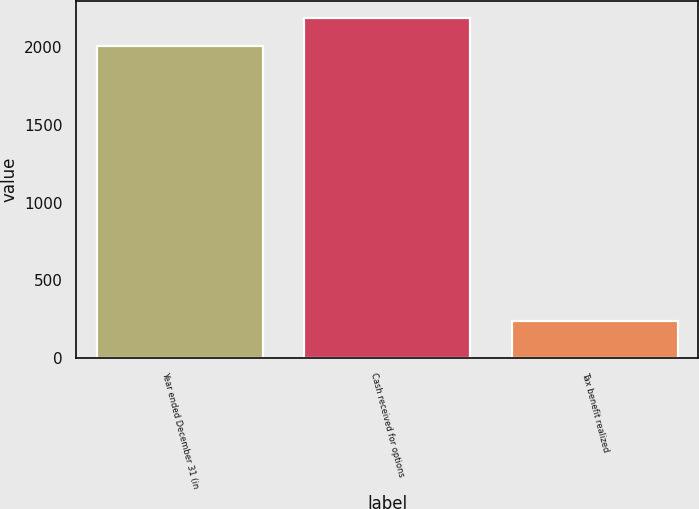Convert chart to OTSL. <chart><loc_0><loc_0><loc_500><loc_500><bar_chart><fcel>Year ended December 31 (in<fcel>Cash received for options<fcel>Tax benefit realized<nl><fcel>2007<fcel>2185.5<fcel>238<nl></chart> 